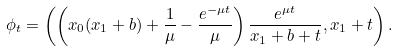<formula> <loc_0><loc_0><loc_500><loc_500>\phi _ { t } = \left ( \left ( x _ { 0 } ( x _ { 1 } + b ) + \frac { 1 } { \mu } - \frac { e ^ { - \mu t } } { \mu } \right ) \frac { e ^ { \mu t } } { x _ { 1 } + b + t } , x _ { 1 } + t \right ) .</formula> 